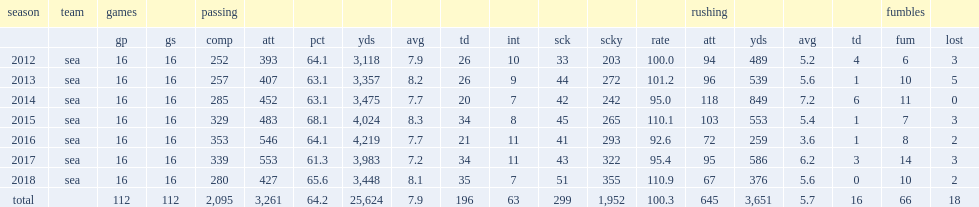How many touchdowns did wilson finish the 2018 with? 35.0. What the passer rating did wilson finish the 2018 with? 110.9. 